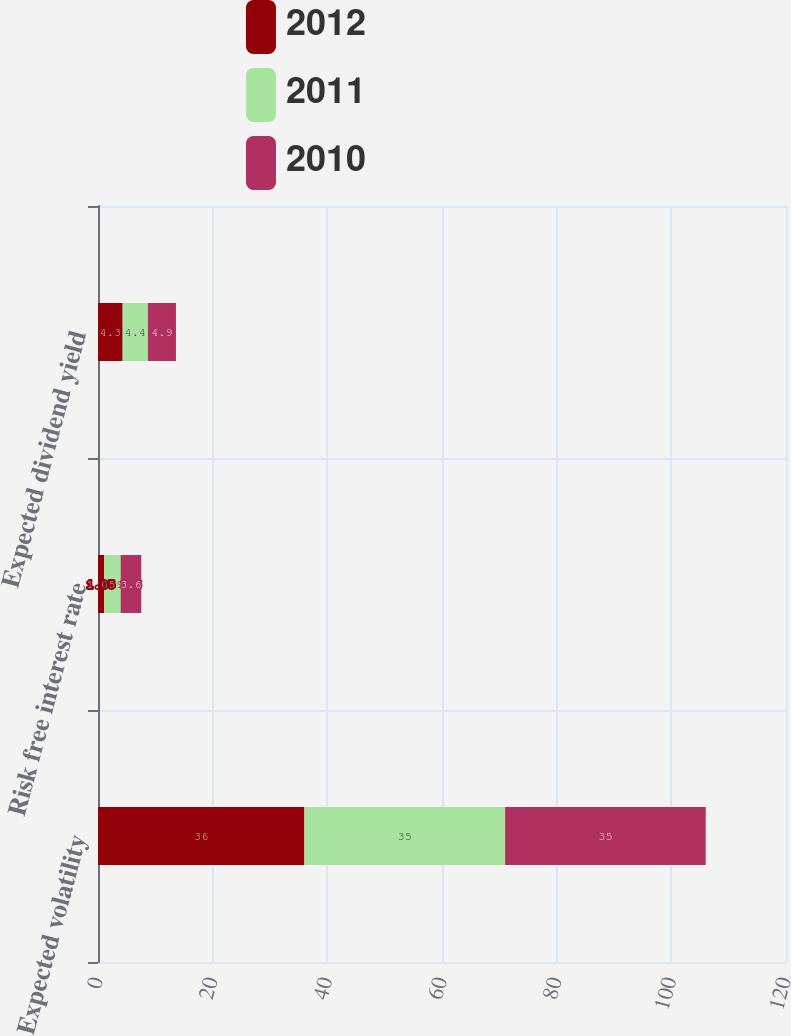Convert chart. <chart><loc_0><loc_0><loc_500><loc_500><stacked_bar_chart><ecel><fcel>Expected volatility<fcel>Risk free interest rate<fcel>Expected dividend yield<nl><fcel>2012<fcel>36<fcel>1.05<fcel>4.3<nl><fcel>2011<fcel>35<fcel>2.9<fcel>4.4<nl><fcel>2010<fcel>35<fcel>3.6<fcel>4.9<nl></chart> 